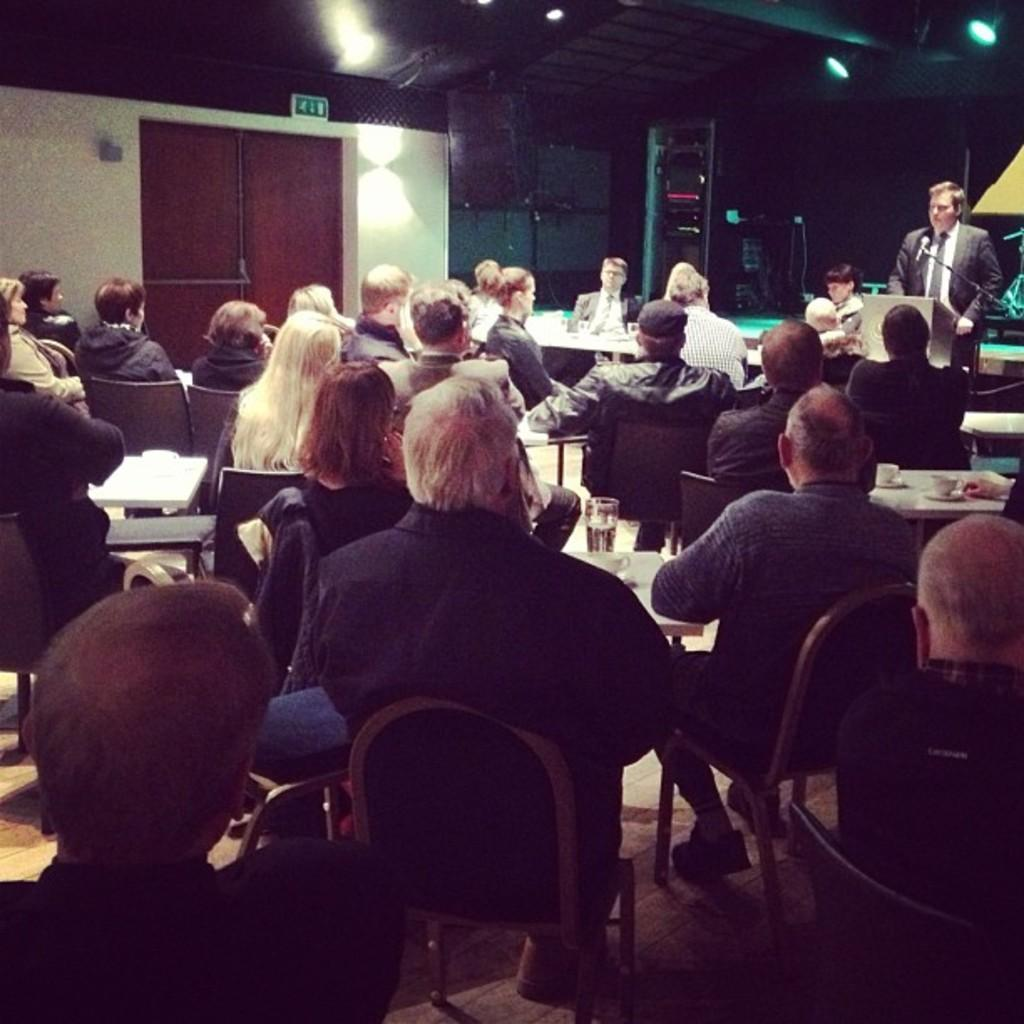What are the people in the image doing? There is a group of people sitting on chairs in the image. What is in front of the chairs? The chairs are in front of a table. What is the man in the image doing? The man is standing in front of a microphone and a podium. What type of bottle can be seen on the podium in the image? There is no bottle present on the podium in the image. 